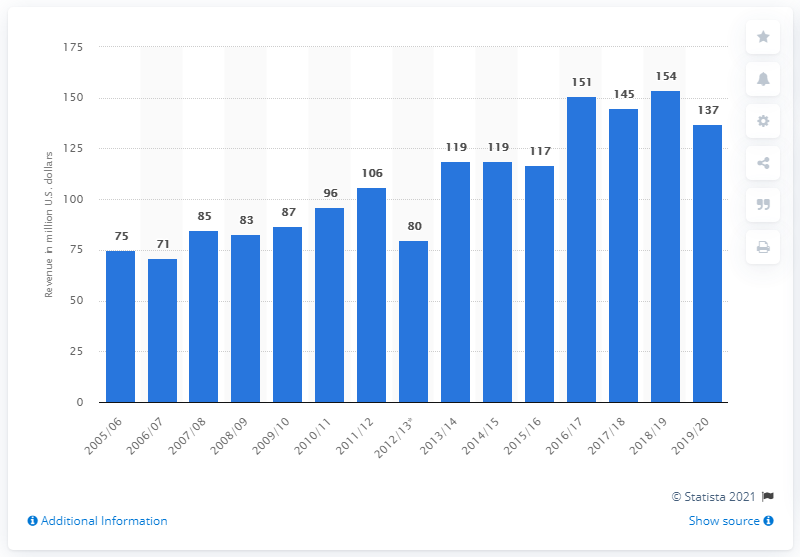Outline some significant characteristics in this image. The Edmonton Oilers earned $137 million in the 2019/2020 season. 